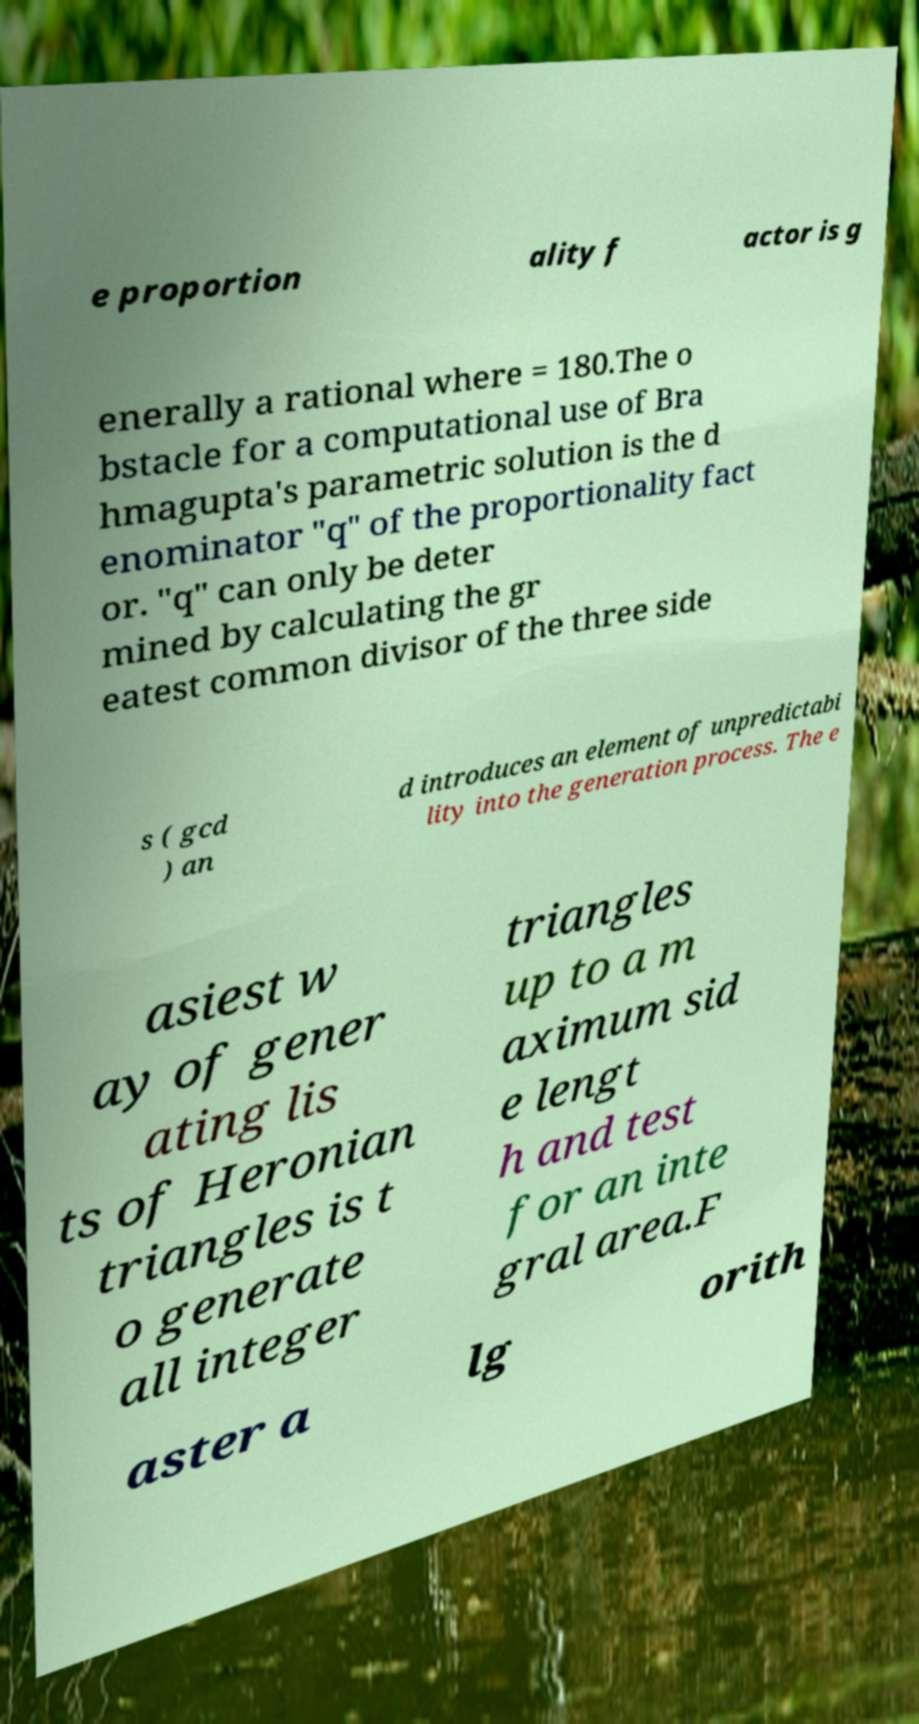Can you read and provide the text displayed in the image?This photo seems to have some interesting text. Can you extract and type it out for me? e proportion ality f actor is g enerally a rational where = 180.The o bstacle for a computational use of Bra hmagupta's parametric solution is the d enominator "q" of the proportionality fact or. "q" can only be deter mined by calculating the gr eatest common divisor of the three side s ( gcd ) an d introduces an element of unpredictabi lity into the generation process. The e asiest w ay of gener ating lis ts of Heronian triangles is t o generate all integer triangles up to a m aximum sid e lengt h and test for an inte gral area.F aster a lg orith 